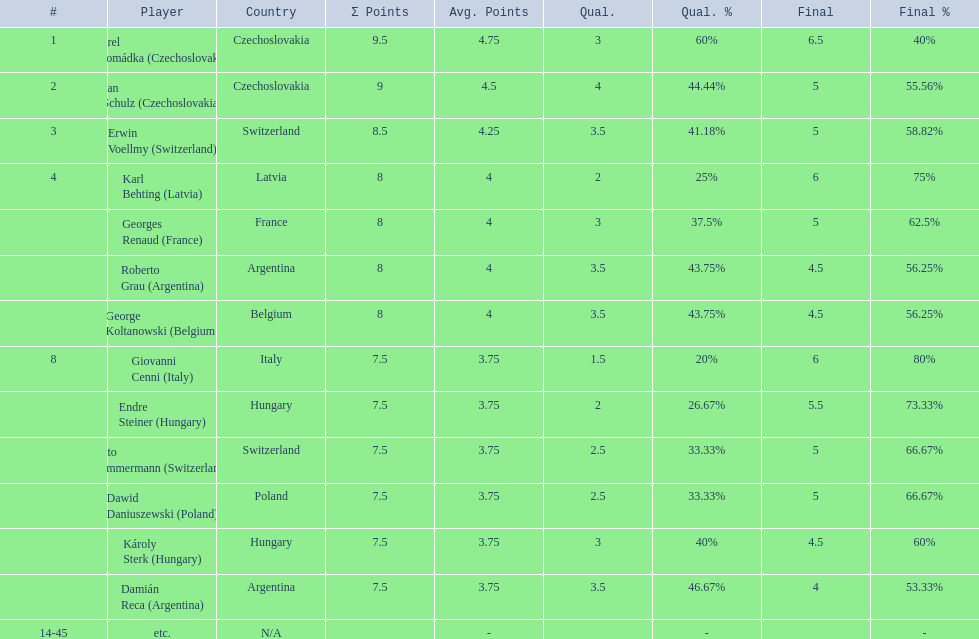The most points were scored by which player? Karel Hromádka. 